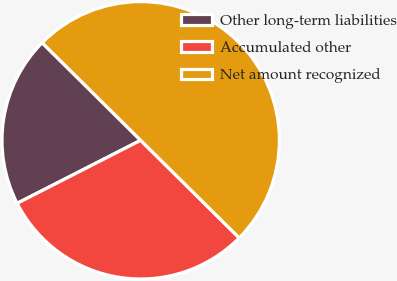Convert chart to OTSL. <chart><loc_0><loc_0><loc_500><loc_500><pie_chart><fcel>Other long-term liabilities<fcel>Accumulated other<fcel>Net amount recognized<nl><fcel>19.93%<fcel>30.07%<fcel>50.0%<nl></chart> 